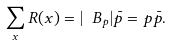<formula> <loc_0><loc_0><loc_500><loc_500>\sum _ { x } R ( x ) = | \ B _ { p } | \bar { p } = p \bar { p } .</formula> 